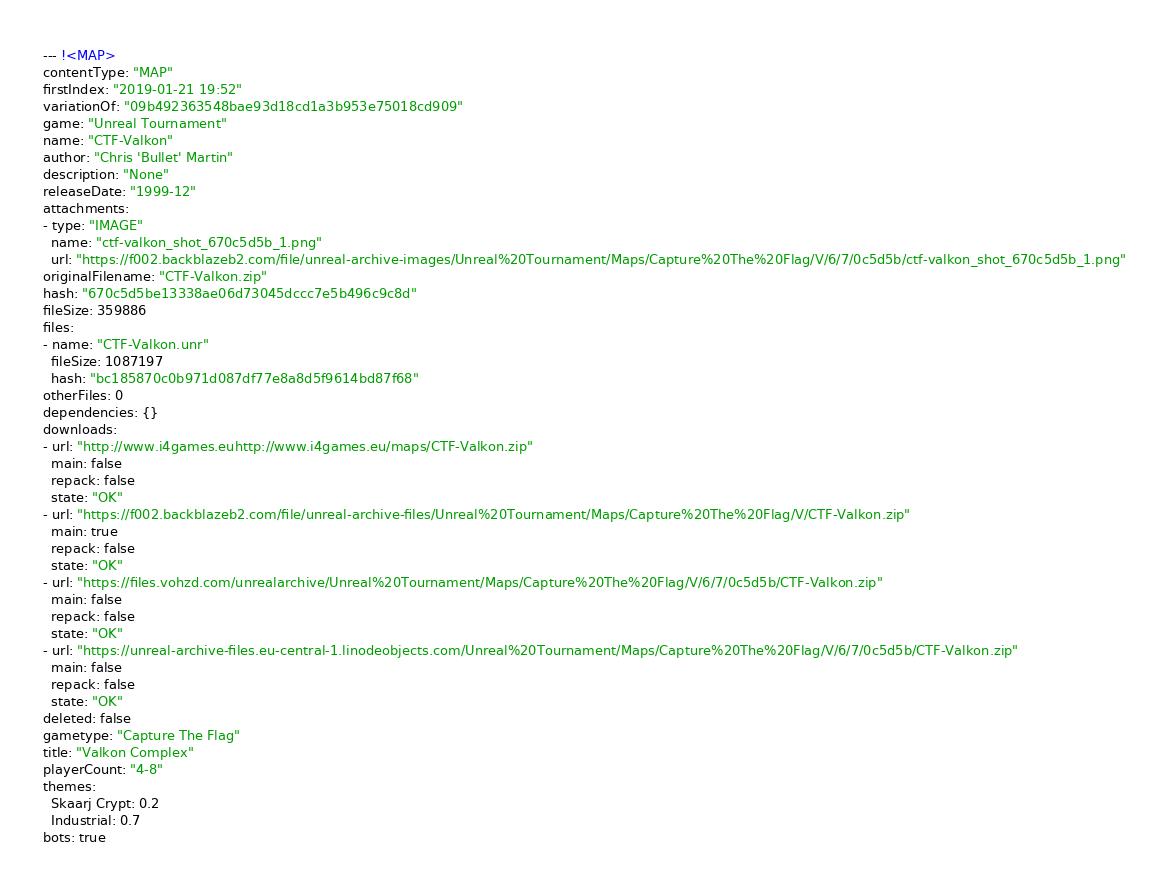Convert code to text. <code><loc_0><loc_0><loc_500><loc_500><_YAML_>--- !<MAP>
contentType: "MAP"
firstIndex: "2019-01-21 19:52"
variationOf: "09b492363548bae93d18cd1a3b953e75018cd909"
game: "Unreal Tournament"
name: "CTF-Valkon"
author: "Chris 'Bullet' Martin"
description: "None"
releaseDate: "1999-12"
attachments:
- type: "IMAGE"
  name: "ctf-valkon_shot_670c5d5b_1.png"
  url: "https://f002.backblazeb2.com/file/unreal-archive-images/Unreal%20Tournament/Maps/Capture%20The%20Flag/V/6/7/0c5d5b/ctf-valkon_shot_670c5d5b_1.png"
originalFilename: "CTF-Valkon.zip"
hash: "670c5d5be13338ae06d73045dccc7e5b496c9c8d"
fileSize: 359886
files:
- name: "CTF-Valkon.unr"
  fileSize: 1087197
  hash: "bc185870c0b971d087df77e8a8d5f9614bd87f68"
otherFiles: 0
dependencies: {}
downloads:
- url: "http://www.i4games.euhttp://www.i4games.eu/maps/CTF-Valkon.zip"
  main: false
  repack: false
  state: "OK"
- url: "https://f002.backblazeb2.com/file/unreal-archive-files/Unreal%20Tournament/Maps/Capture%20The%20Flag/V/CTF-Valkon.zip"
  main: true
  repack: false
  state: "OK"
- url: "https://files.vohzd.com/unrealarchive/Unreal%20Tournament/Maps/Capture%20The%20Flag/V/6/7/0c5d5b/CTF-Valkon.zip"
  main: false
  repack: false
  state: "OK"
- url: "https://unreal-archive-files.eu-central-1.linodeobjects.com/Unreal%20Tournament/Maps/Capture%20The%20Flag/V/6/7/0c5d5b/CTF-Valkon.zip"
  main: false
  repack: false
  state: "OK"
deleted: false
gametype: "Capture The Flag"
title: "Valkon Complex"
playerCount: "4-8"
themes:
  Skaarj Crypt: 0.2
  Industrial: 0.7
bots: true
</code> 